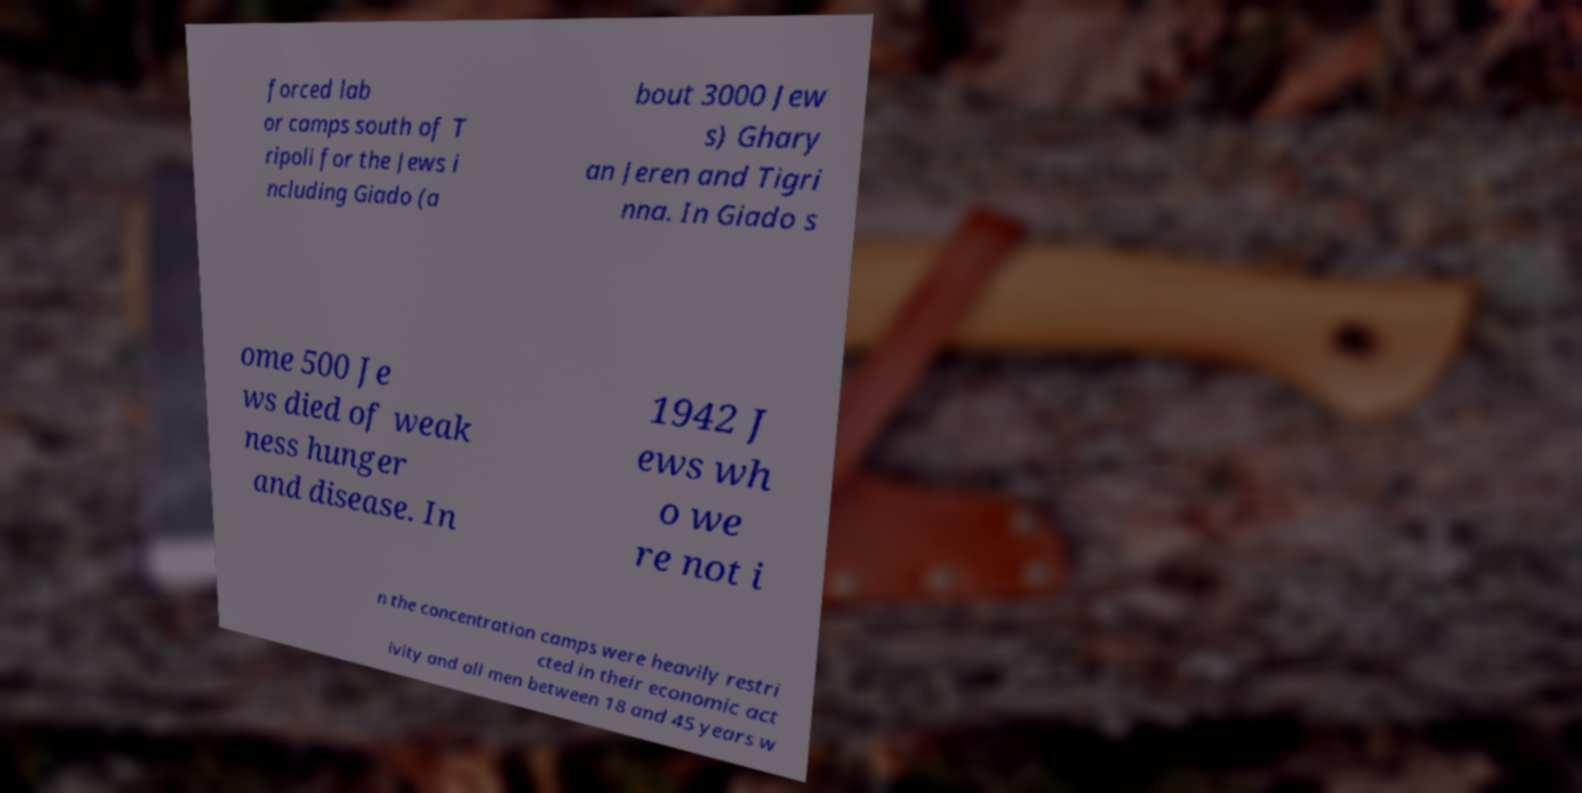Could you assist in decoding the text presented in this image and type it out clearly? forced lab or camps south of T ripoli for the Jews i ncluding Giado (a bout 3000 Jew s) Ghary an Jeren and Tigri nna. In Giado s ome 500 Je ws died of weak ness hunger and disease. In 1942 J ews wh o we re not i n the concentration camps were heavily restri cted in their economic act ivity and all men between 18 and 45 years w 